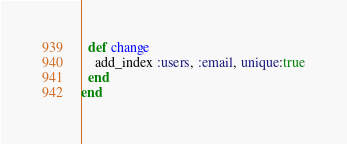<code> <loc_0><loc_0><loc_500><loc_500><_Ruby_>  def change
    add_index :users, :email, unique:true
  end
end
</code> 